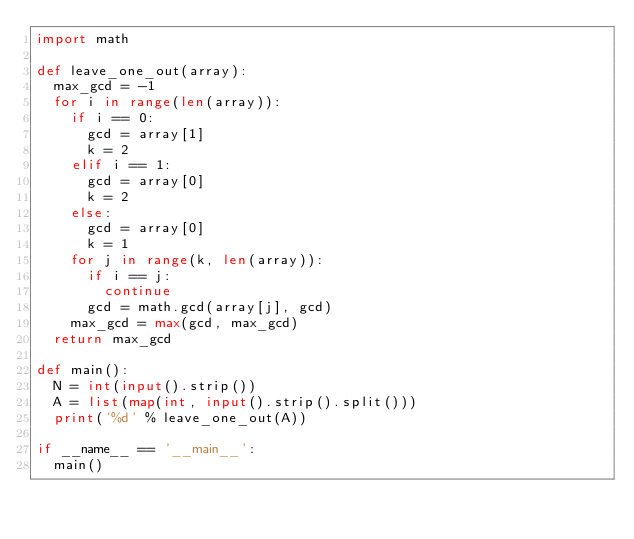Convert code to text. <code><loc_0><loc_0><loc_500><loc_500><_Python_>import math

def leave_one_out(array):
  max_gcd = -1
  for i in range(len(array)):
    if i == 0:
      gcd = array[1]
      k = 2
    elif i == 1:
      gcd = array[0]
      k = 2
    else:
      gcd = array[0]
      k = 1
    for j in range(k, len(array)):
      if i == j:
        continue
      gcd = math.gcd(array[j], gcd)
    max_gcd = max(gcd, max_gcd)
  return max_gcd

def main():
  N = int(input().strip())
  A = list(map(int, input().strip().split()))
  print('%d' % leave_one_out(A))

if __name__ == '__main__':
  main()
</code> 